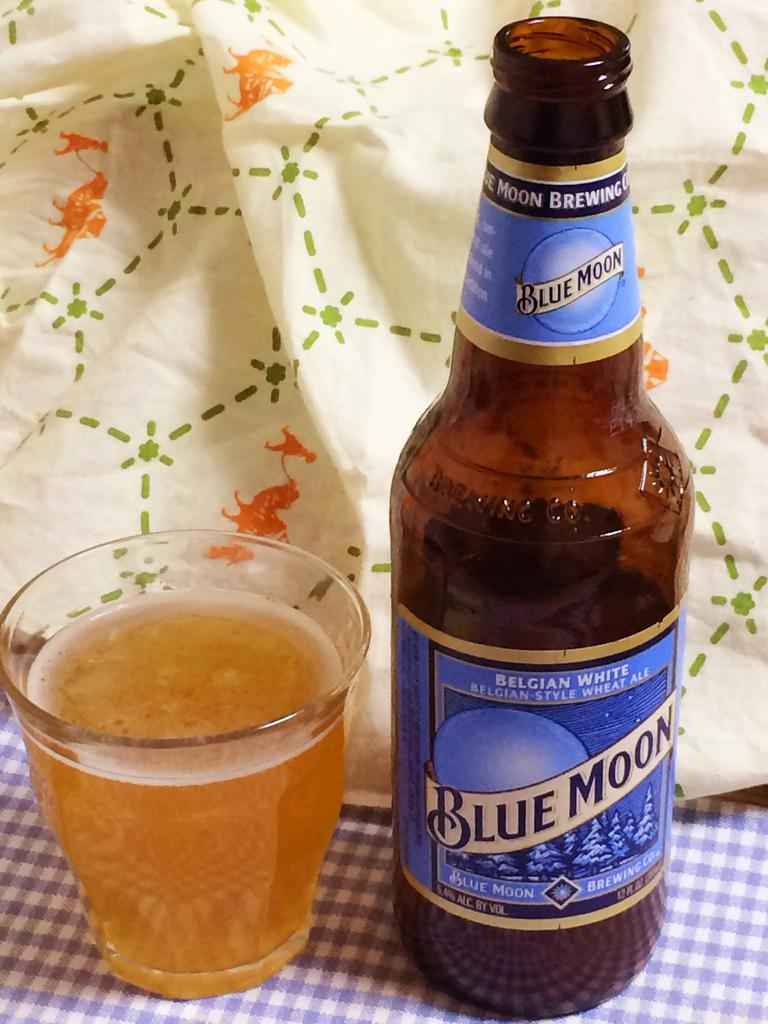What type of beverage is present in the image? There is a beer bottle and a glass filled with beer in the image. Where is the glass placed in the image? The glass is on a table cloth. How does the family show respect to the beam in the image? There is no family or beam present in the image; it only features a beer bottle and a glass filled with beer on a table cloth. 